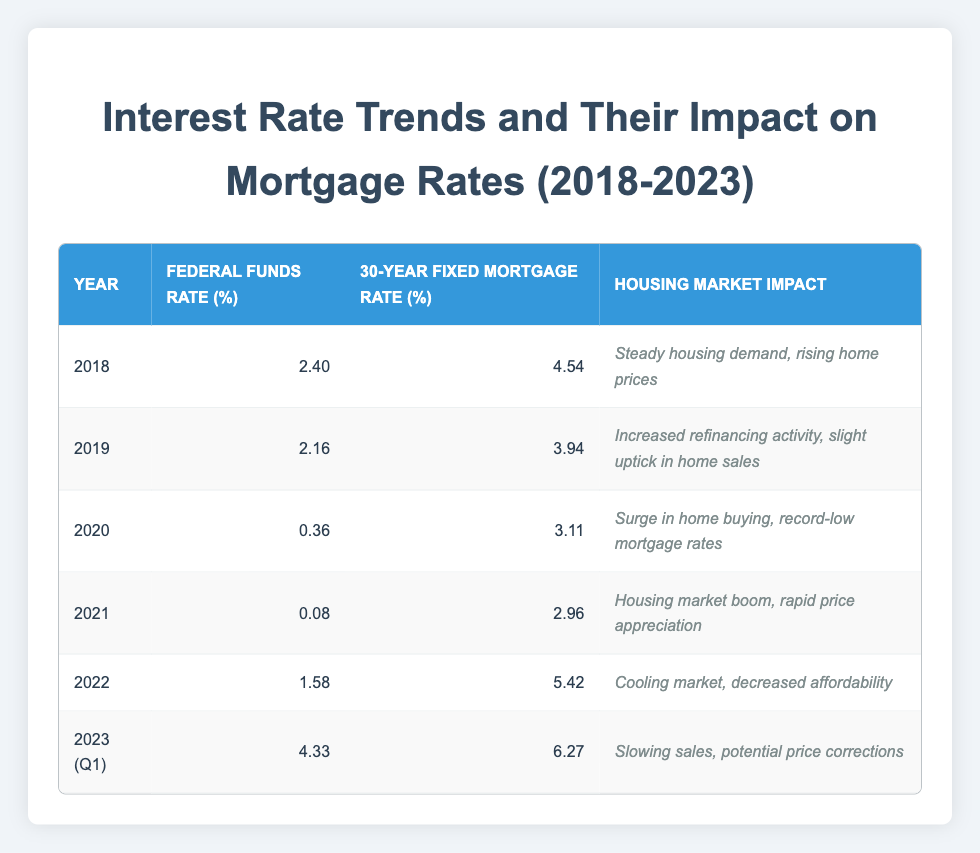What was the federal funds rate in 2020? According to the table, the federal funds rate in 2020 is listed as 0.36%.
Answer: 0.36% In which year did the 30-year fixed mortgage rate reach its peak? By reviewing the mortgage rates, 2023 shows the highest value at 6.27%.
Answer: 2023 What was the average federal funds rate from 2018 to 2023? First, sum the federal funds rates: (2.40 + 2.16 + 0.36 + 0.08 + 1.58 + 4.33) = 10.91. Next, there are 6 years, so the average is 10.91/6 = 1.8183 which rounds to about 1.82%.
Answer: 1.82% Was there a decrease in the 30-year fixed mortgage rate from 2019 to 2020? Comparing the two values: 3.94% (2019) and 3.11% (2020), we see that the rate decreased from 2019 to 2020.
Answer: Yes What impact did the federal funds rate increase from 2021 to 2022 have on the housing market? The federal funds rate increased from 0.08% in 2021 to 1.58% in 2022, which contributed to a cooling market and decreased affordability as shown in the table.
Answer: Cooling market, decreased affordability In what year was the lowest 30-year fixed mortgage rate recorded, and what was that rate? The table indicates that the lowest mortgage rate is in 2021, at 2.96%.
Answer: 2021, 2.96% How many years experienced a decrease in the federal funds rate? Looking at the data, 2018 to 2019 and 2020 to 2021 show decreases, resulting in a total of 2 years with decreases.
Answer: 2 What housing market impact is associated with the federal funds rate of 4.33% in Q1 2023? The impact associated with this rate is a slowing of sales and potential price corrections, as indicated in the table.
Answer: Slowing sales, potential price corrections 